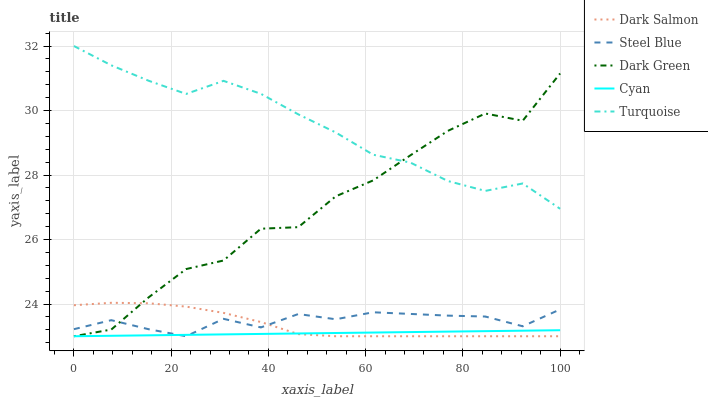Does Cyan have the minimum area under the curve?
Answer yes or no. Yes. Does Turquoise have the maximum area under the curve?
Answer yes or no. Yes. Does Dark Green have the minimum area under the curve?
Answer yes or no. No. Does Dark Green have the maximum area under the curve?
Answer yes or no. No. Is Cyan the smoothest?
Answer yes or no. Yes. Is Dark Green the roughest?
Answer yes or no. Yes. Is Turquoise the smoothest?
Answer yes or no. No. Is Turquoise the roughest?
Answer yes or no. No. Does Cyan have the lowest value?
Answer yes or no. Yes. Does Turquoise have the lowest value?
Answer yes or no. No. Does Turquoise have the highest value?
Answer yes or no. Yes. Does Dark Green have the highest value?
Answer yes or no. No. Is Dark Salmon less than Turquoise?
Answer yes or no. Yes. Is Turquoise greater than Steel Blue?
Answer yes or no. Yes. Does Cyan intersect Dark Salmon?
Answer yes or no. Yes. Is Cyan less than Dark Salmon?
Answer yes or no. No. Is Cyan greater than Dark Salmon?
Answer yes or no. No. Does Dark Salmon intersect Turquoise?
Answer yes or no. No. 